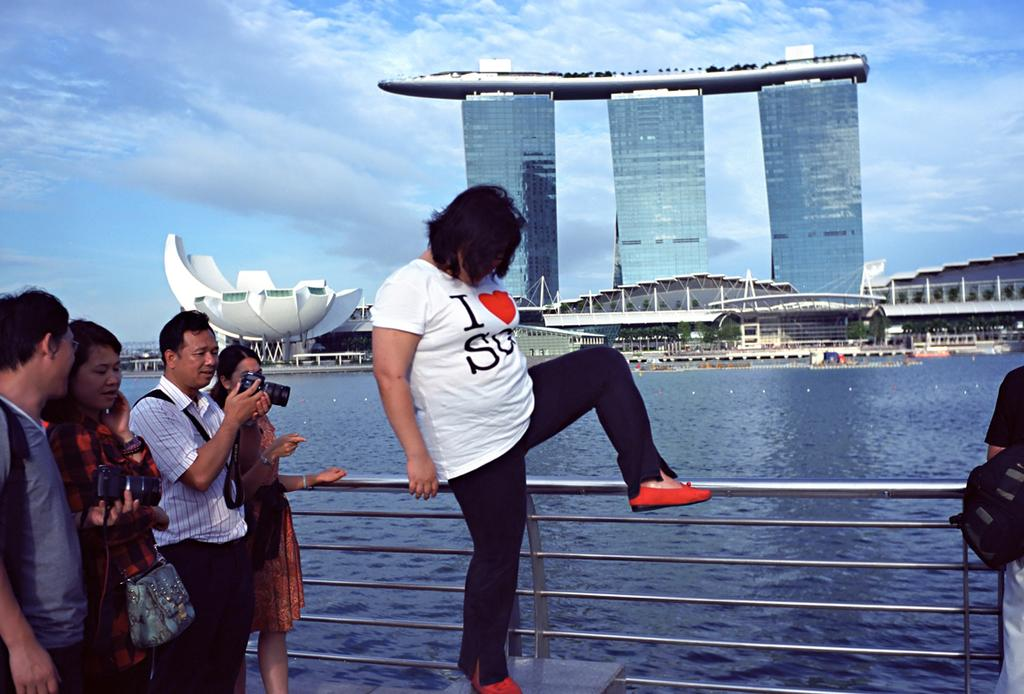How many people are in the image? There are people in the image, but the exact number is not specified. What are two of the people doing in the image? Two of the people are holding cameras in the image. What type of structure can be seen in the image? There is fencing, buildings, and poles in the image. What part of the natural environment is visible in the image? The sky and a river are visible in the image. What type of cracker is the daughter eating in the image? There is no mention of a daughter or any crackers in the image. 